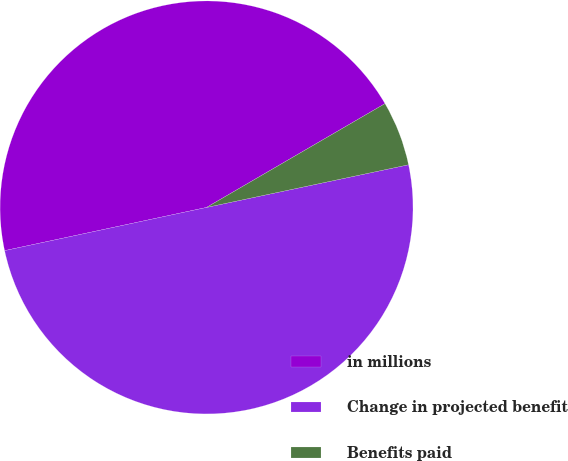Convert chart. <chart><loc_0><loc_0><loc_500><loc_500><pie_chart><fcel>in millions<fcel>Change in projected benefit<fcel>Benefits paid<nl><fcel>44.97%<fcel>49.96%<fcel>5.07%<nl></chart> 